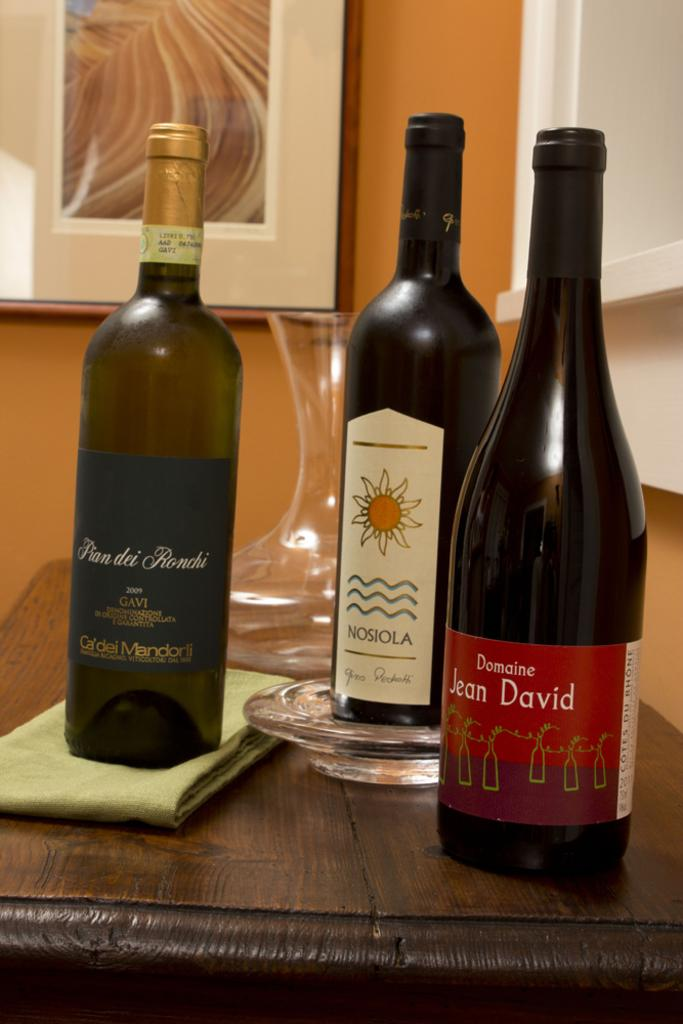Provide a one-sentence caption for the provided image. Three bottles of wine, including once called Duncine Jean David, sit on a table in front of a clear vase. 